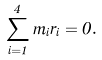<formula> <loc_0><loc_0><loc_500><loc_500>\sum _ { i = 1 } ^ { 4 } m _ { i } { r } _ { i } = 0 .</formula> 